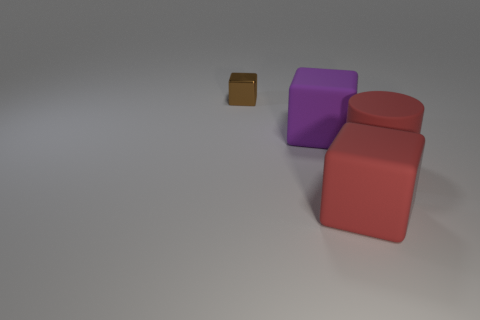Add 2 large red cylinders. How many objects exist? 6 Subtract all blocks. How many objects are left? 1 Add 1 red cylinders. How many red cylinders exist? 2 Subtract 0 yellow cylinders. How many objects are left? 4 Subtract all yellow rubber cylinders. Subtract all small metallic blocks. How many objects are left? 3 Add 4 large red cylinders. How many large red cylinders are left? 5 